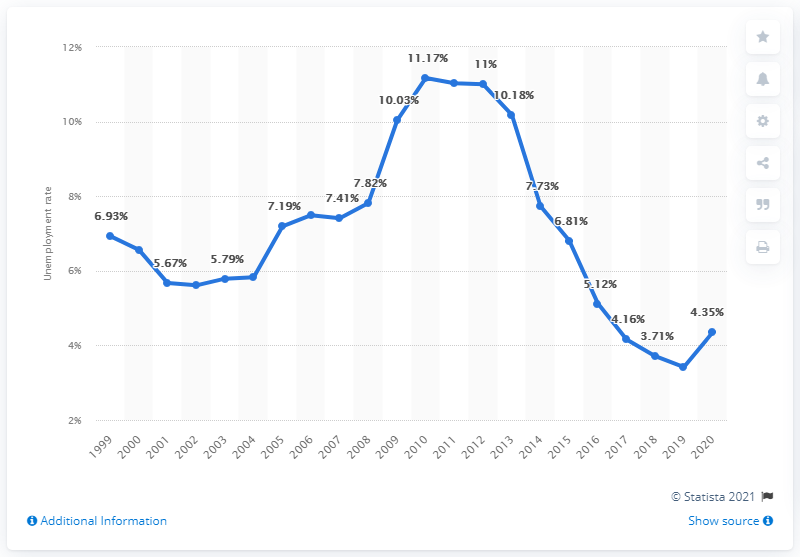Specify some key components in this picture. According to data from 2020, the unemployment rate in Hungary was 4.35%. 